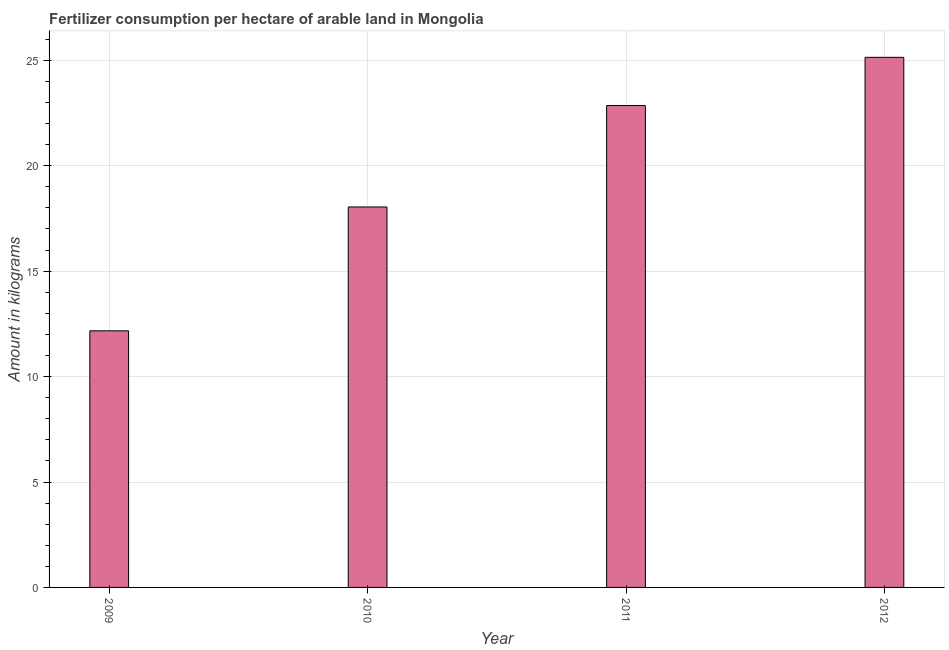Does the graph contain grids?
Your response must be concise. Yes. What is the title of the graph?
Your answer should be very brief. Fertilizer consumption per hectare of arable land in Mongolia . What is the label or title of the Y-axis?
Offer a very short reply. Amount in kilograms. What is the amount of fertilizer consumption in 2010?
Give a very brief answer. 18.05. Across all years, what is the maximum amount of fertilizer consumption?
Offer a terse response. 25.14. Across all years, what is the minimum amount of fertilizer consumption?
Your response must be concise. 12.17. What is the sum of the amount of fertilizer consumption?
Provide a succinct answer. 78.21. What is the difference between the amount of fertilizer consumption in 2009 and 2010?
Your answer should be very brief. -5.88. What is the average amount of fertilizer consumption per year?
Your response must be concise. 19.55. What is the median amount of fertilizer consumption?
Provide a succinct answer. 20.45. In how many years, is the amount of fertilizer consumption greater than 25 kg?
Provide a short and direct response. 1. What is the ratio of the amount of fertilizer consumption in 2009 to that in 2011?
Your answer should be compact. 0.53. What is the difference between the highest and the second highest amount of fertilizer consumption?
Keep it short and to the point. 2.29. Is the sum of the amount of fertilizer consumption in 2009 and 2011 greater than the maximum amount of fertilizer consumption across all years?
Offer a terse response. Yes. What is the difference between the highest and the lowest amount of fertilizer consumption?
Give a very brief answer. 12.97. In how many years, is the amount of fertilizer consumption greater than the average amount of fertilizer consumption taken over all years?
Your answer should be very brief. 2. Are all the bars in the graph horizontal?
Keep it short and to the point. No. Are the values on the major ticks of Y-axis written in scientific E-notation?
Your response must be concise. No. What is the Amount in kilograms in 2009?
Your answer should be compact. 12.17. What is the Amount in kilograms in 2010?
Make the answer very short. 18.05. What is the Amount in kilograms in 2011?
Ensure brevity in your answer.  22.86. What is the Amount in kilograms of 2012?
Provide a succinct answer. 25.14. What is the difference between the Amount in kilograms in 2009 and 2010?
Your response must be concise. -5.88. What is the difference between the Amount in kilograms in 2009 and 2011?
Your answer should be compact. -10.69. What is the difference between the Amount in kilograms in 2009 and 2012?
Keep it short and to the point. -12.97. What is the difference between the Amount in kilograms in 2010 and 2011?
Your answer should be compact. -4.81. What is the difference between the Amount in kilograms in 2010 and 2012?
Offer a very short reply. -7.1. What is the difference between the Amount in kilograms in 2011 and 2012?
Provide a short and direct response. -2.29. What is the ratio of the Amount in kilograms in 2009 to that in 2010?
Give a very brief answer. 0.67. What is the ratio of the Amount in kilograms in 2009 to that in 2011?
Offer a terse response. 0.53. What is the ratio of the Amount in kilograms in 2009 to that in 2012?
Offer a terse response. 0.48. What is the ratio of the Amount in kilograms in 2010 to that in 2011?
Your response must be concise. 0.79. What is the ratio of the Amount in kilograms in 2010 to that in 2012?
Provide a succinct answer. 0.72. What is the ratio of the Amount in kilograms in 2011 to that in 2012?
Offer a very short reply. 0.91. 